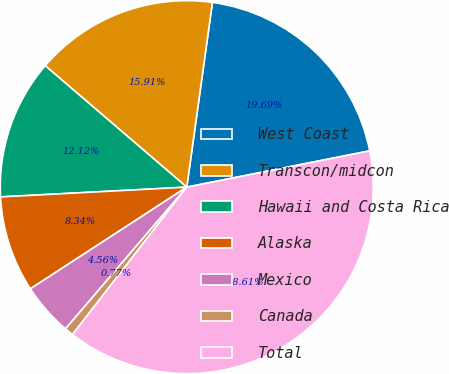<chart> <loc_0><loc_0><loc_500><loc_500><pie_chart><fcel>West Coast<fcel>Transcon/midcon<fcel>Hawaii and Costa Rica<fcel>Alaska<fcel>Mexico<fcel>Canada<fcel>Total<nl><fcel>19.69%<fcel>15.91%<fcel>12.12%<fcel>8.34%<fcel>4.56%<fcel>0.77%<fcel>38.61%<nl></chart> 